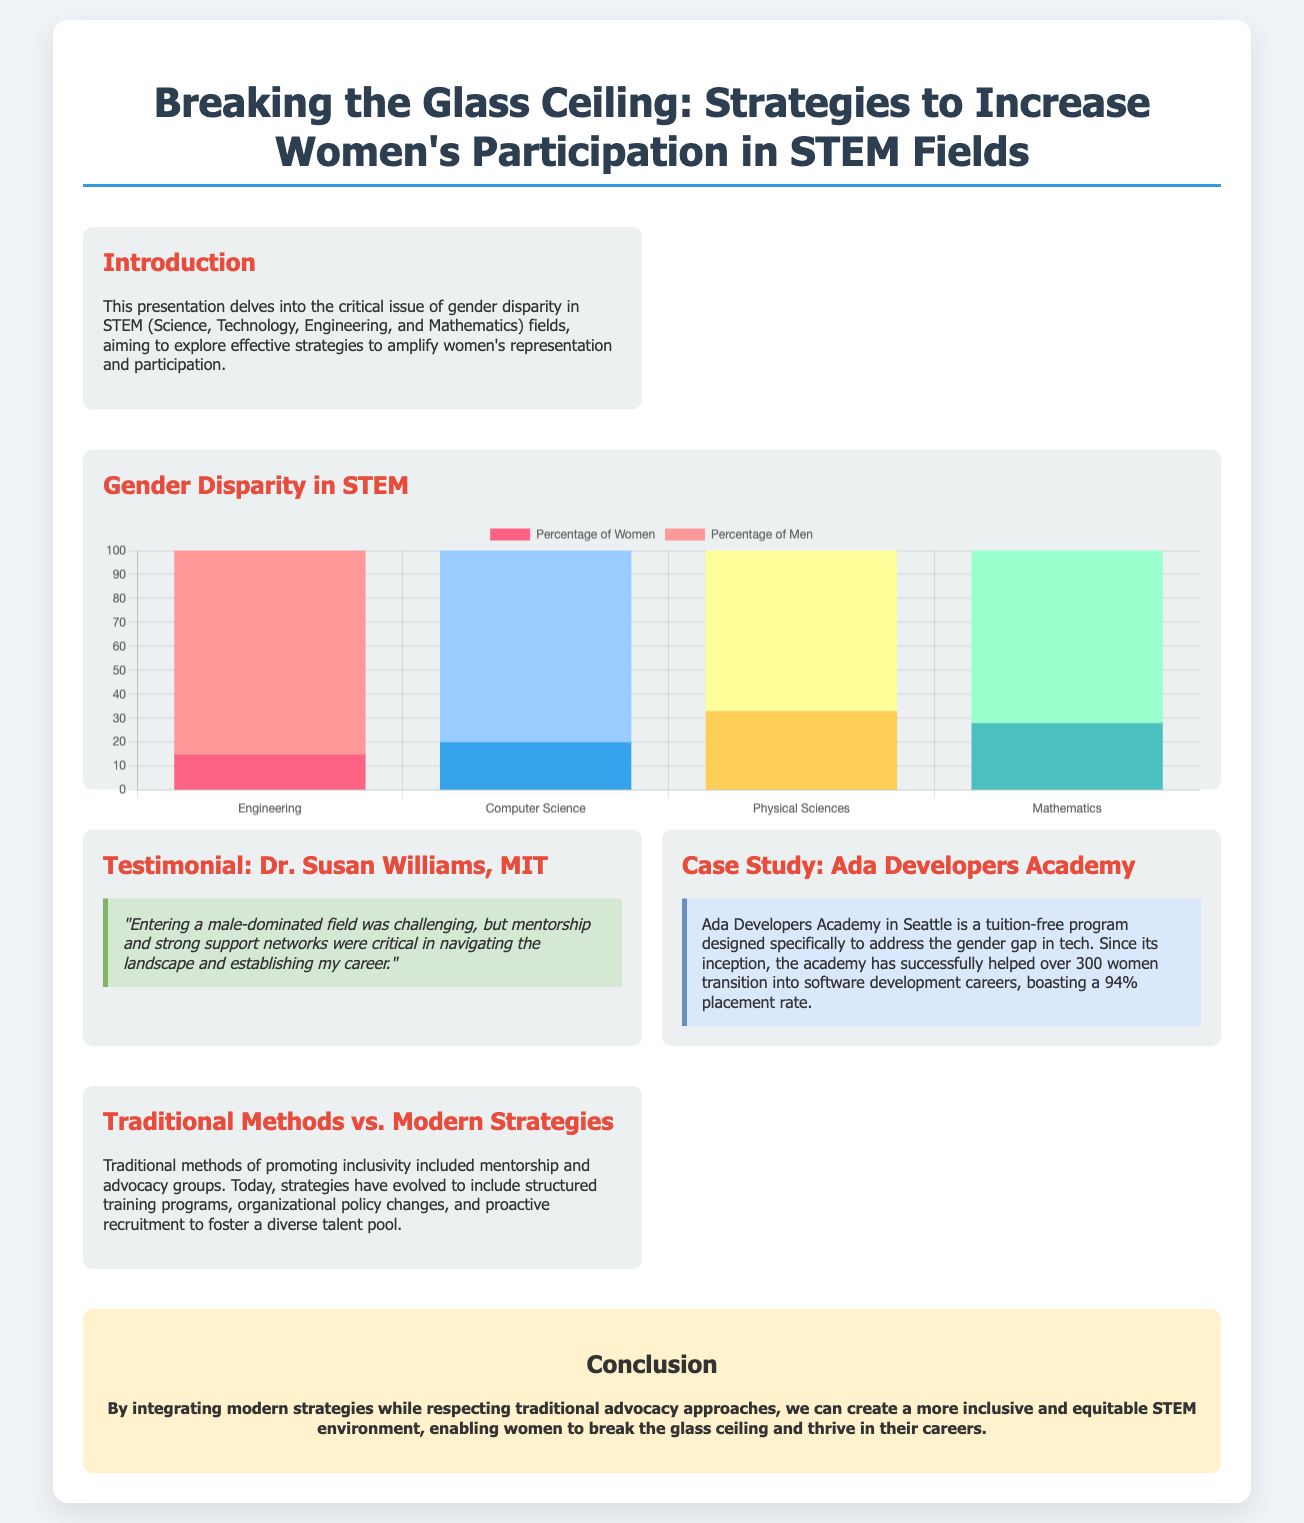What is the title of the presentation? The title is explicitly mentioned at the top of the document.
Answer: Breaking the Glass Ceiling: Strategies to Increase Women's Participation in STEM Fields What is the percentage of women in Engineering according to the chart? The chart displays the distribution of women in various STEM fields, with Engineering specifically labeled.
Answer: 15 What is Dr. Susan Williams' affiliation? The document states Dr. Susan Williams' institutional affiliation in her testimonial section.
Answer: MIT What is the placement rate for Ada Developers Academy graduates? The case study provides specific success metrics regarding the graduates of the program.
Answer: 94% What are the four fields represented in the gender disparity chart? The chart lists fields for the comparison of gender percentages.
Answer: Engineering, Computer Science, Physical Sciences, Mathematics What traditional method is mentioned in relation to promoting inclusivity? The document references long-standing strategies used in engaging women in STEM.
Answer: Mentorship How many women has Ada Developers Academy helped transition into software development careers? This figure is provided in the case study of the academy.
Answer: Over 300 What two approaches are integrated in the conclusion to promote inclusivity? The conclusion section discusses both modern and traditional strategies for improving women's participation.
Answer: Modern strategies and traditional advocacy approaches What is the color associated with the percentage of men in Computer Science? The chart assigns specific colors to differentiate gender percentages in various fields.
Answer: Light Blue 